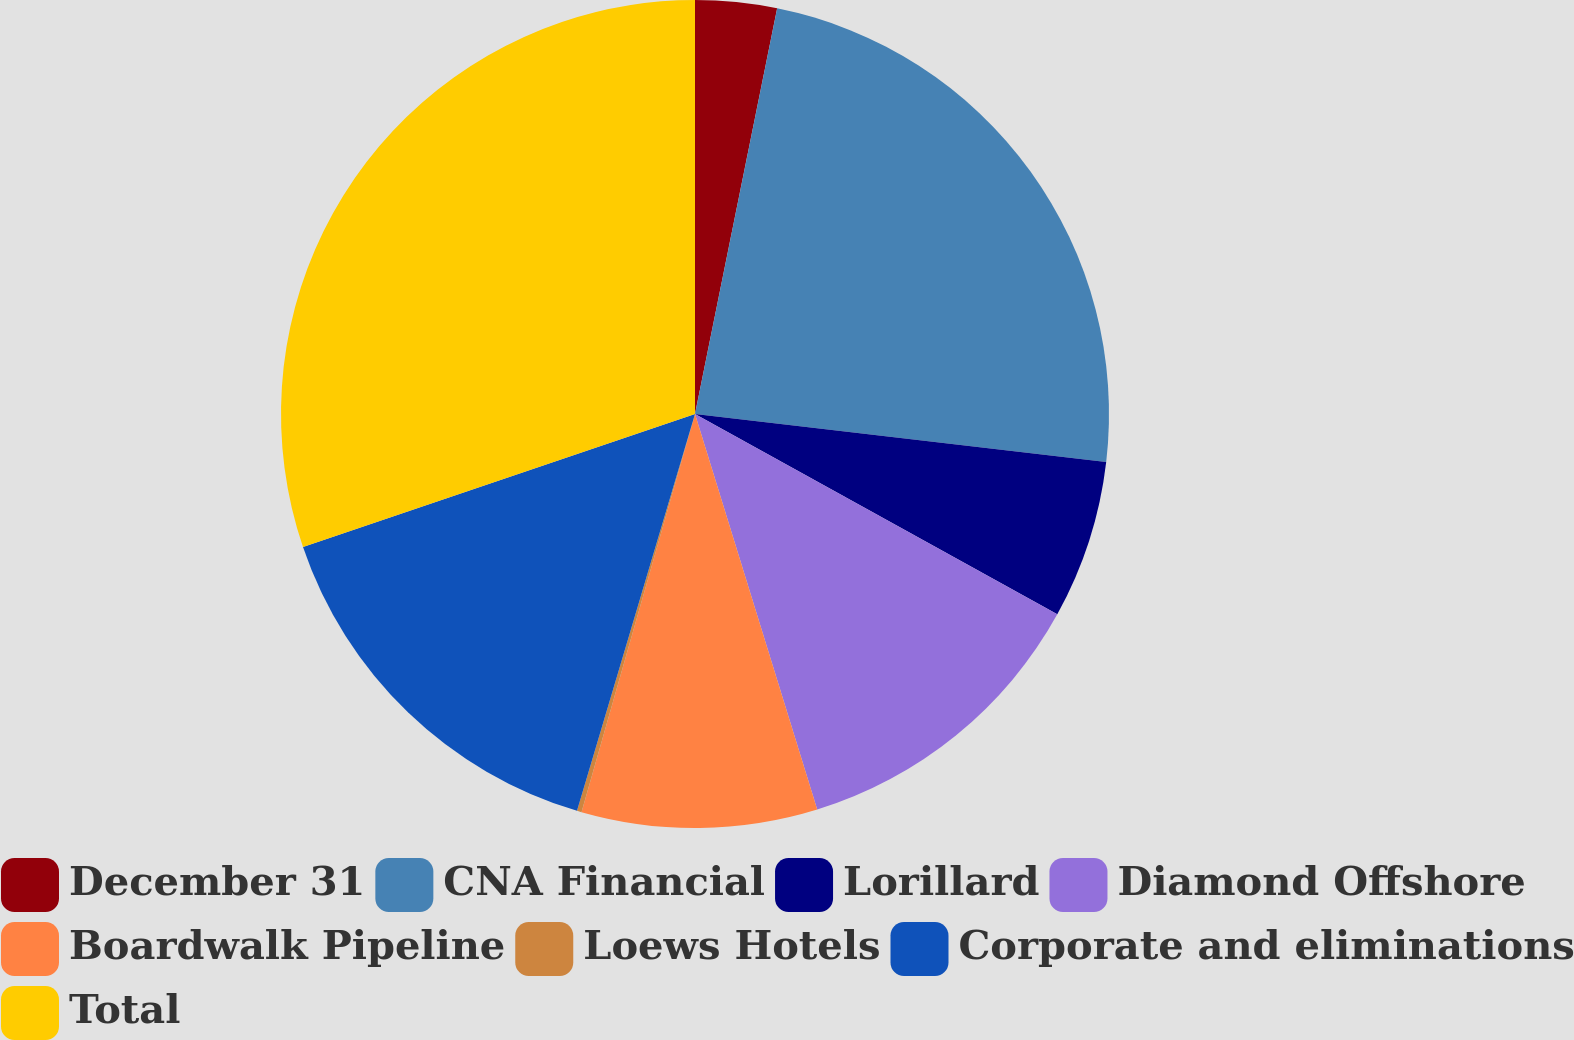Convert chart. <chart><loc_0><loc_0><loc_500><loc_500><pie_chart><fcel>December 31<fcel>CNA Financial<fcel>Lorillard<fcel>Diamond Offshore<fcel>Boardwalk Pipeline<fcel>Loews Hotels<fcel>Corporate and eliminations<fcel>Total<nl><fcel>3.18%<fcel>23.67%<fcel>6.19%<fcel>12.19%<fcel>9.19%<fcel>0.18%<fcel>15.19%<fcel>30.21%<nl></chart> 